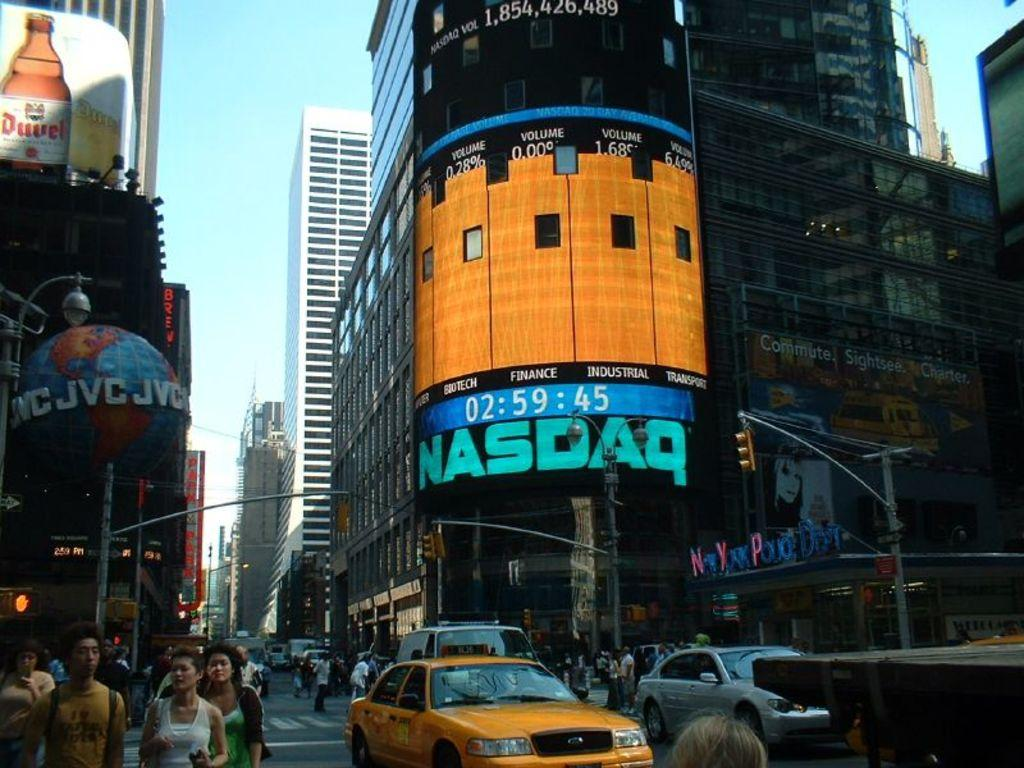<image>
Summarize the visual content of the image. a NASDAQ sign that is located outside in day 